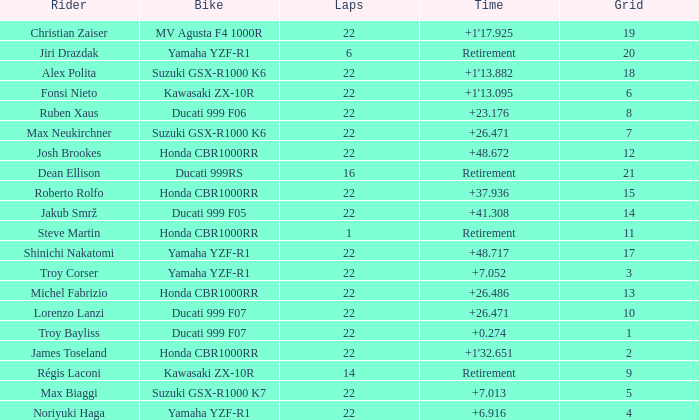What is the total grid number when Fonsi Nieto had more than 22 laps? 0.0. Would you be able to parse every entry in this table? {'header': ['Rider', 'Bike', 'Laps', 'Time', 'Grid'], 'rows': [['Christian Zaiser', 'MV Agusta F4 1000R', '22', "+1'17.925", '19'], ['Jiri Drazdak', 'Yamaha YZF-R1', '6', 'Retirement', '20'], ['Alex Polita', 'Suzuki GSX-R1000 K6', '22', "+1'13.882", '18'], ['Fonsi Nieto', 'Kawasaki ZX-10R', '22', "+1'13.095", '6'], ['Ruben Xaus', 'Ducati 999 F06', '22', '+23.176', '8'], ['Max Neukirchner', 'Suzuki GSX-R1000 K6', '22', '+26.471', '7'], ['Josh Brookes', 'Honda CBR1000RR', '22', '+48.672', '12'], ['Dean Ellison', 'Ducati 999RS', '16', 'Retirement', '21'], ['Roberto Rolfo', 'Honda CBR1000RR', '22', '+37.936', '15'], ['Jakub Smrž', 'Ducati 999 F05', '22', '+41.308', '14'], ['Steve Martin', 'Honda CBR1000RR', '1', 'Retirement', '11'], ['Shinichi Nakatomi', 'Yamaha YZF-R1', '22', '+48.717', '17'], ['Troy Corser', 'Yamaha YZF-R1', '22', '+7.052', '3'], ['Michel Fabrizio', 'Honda CBR1000RR', '22', '+26.486', '13'], ['Lorenzo Lanzi', 'Ducati 999 F07', '22', '+26.471', '10'], ['Troy Bayliss', 'Ducati 999 F07', '22', '+0.274', '1'], ['James Toseland', 'Honda CBR1000RR', '22', "+1'32.651", '2'], ['Régis Laconi', 'Kawasaki ZX-10R', '14', 'Retirement', '9'], ['Max Biaggi', 'Suzuki GSX-R1000 K7', '22', '+7.013', '5'], ['Noriyuki Haga', 'Yamaha YZF-R1', '22', '+6.916', '4']]} 